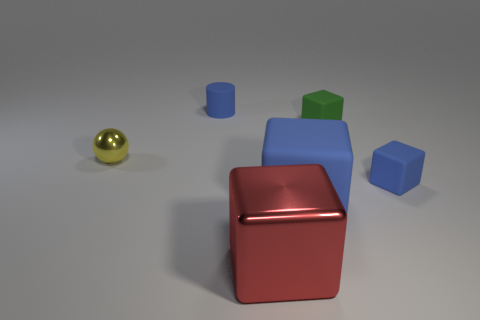There is a green object that is the same shape as the big red thing; what is its size?
Ensure brevity in your answer.  Small. What material is the small object that is the same color as the rubber cylinder?
Give a very brief answer. Rubber. What material is the large red object that is the same shape as the large blue object?
Provide a short and direct response. Metal. Is the material of the large red thing the same as the small green thing?
Your answer should be very brief. No. There is a yellow shiny thing that is the same size as the blue cylinder; what is its shape?
Your response must be concise. Sphere. Are there more tiny yellow matte cylinders than rubber things?
Provide a succinct answer. No. There is a thing that is behind the small yellow sphere and to the right of the big metallic thing; what material is it made of?
Your response must be concise. Rubber. What number of other objects are the same material as the green object?
Your answer should be very brief. 3. How many small cylinders have the same color as the big metal thing?
Your response must be concise. 0. There is a rubber object behind the tiny rubber cube behind the yellow metal ball that is on the left side of the small blue rubber cylinder; what is its size?
Your answer should be compact. Small. 